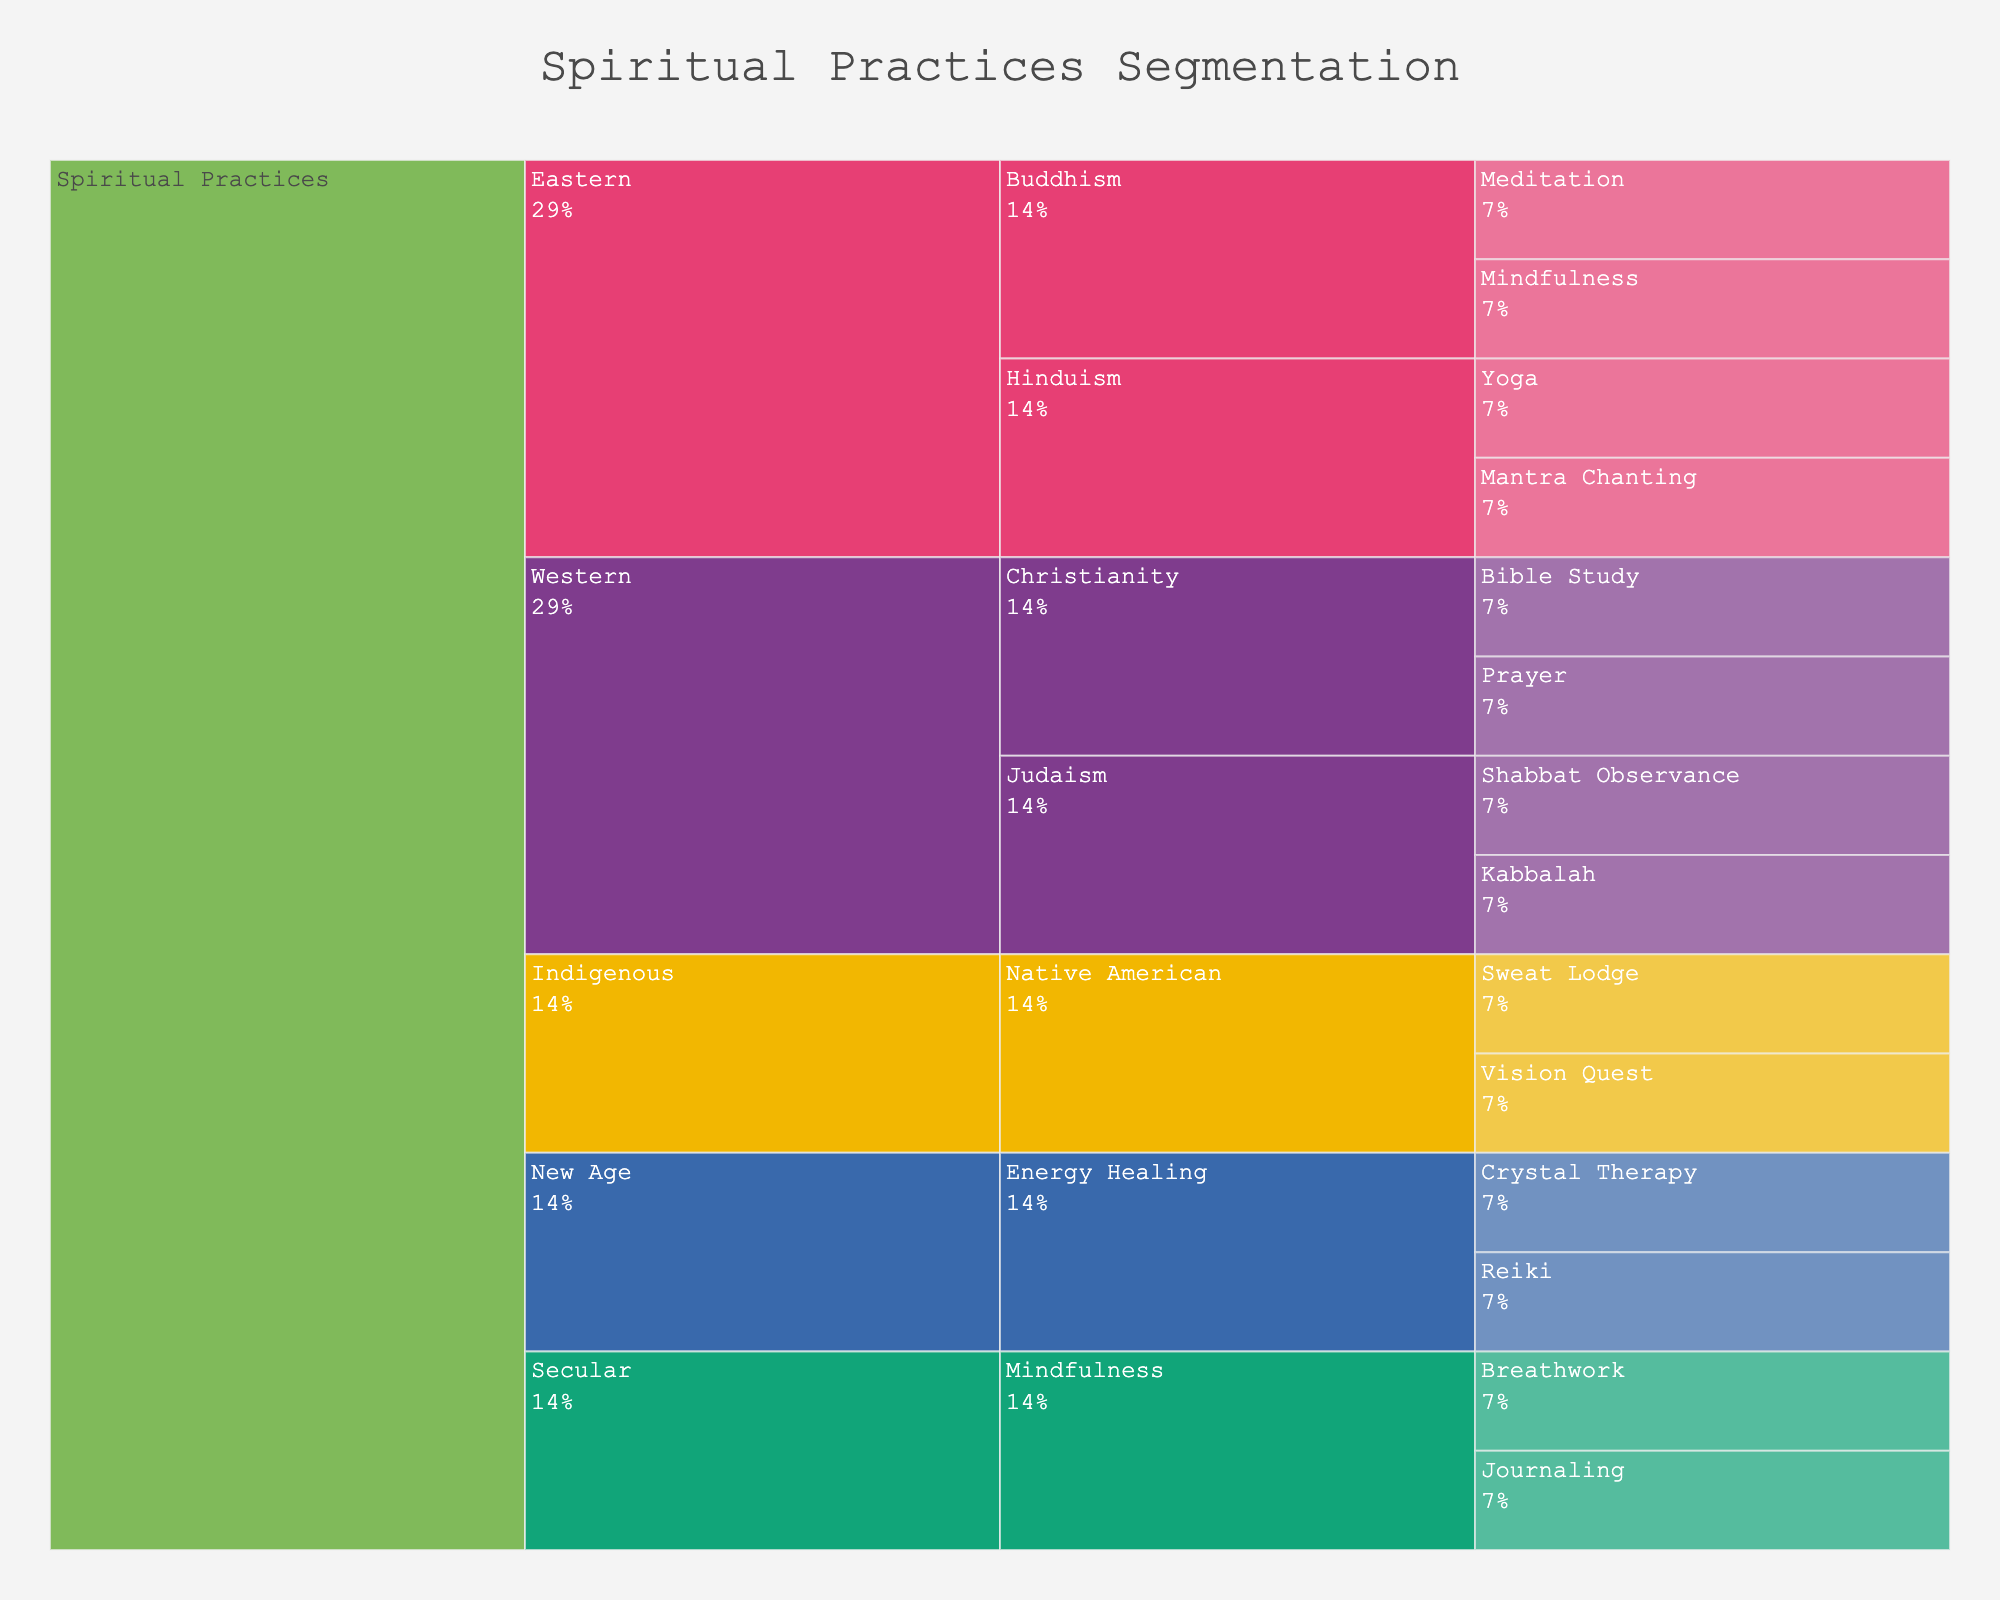What is the title of the figure? The title is usually located at the top center of the chart.
Answer: Spiritual Practices Segmentation Which belief system under "Western" has the most practices listed? Look at the branches stemming from "Western" and compare the number of practices under each belief system.
Answer: Christianity How many practices are listed under "Eastern"? Count all the practices that fall under the "Eastern" category.
Answer: 4 How does the number of practices in "New Age" compare to "Secular"? Count the practices under each category and compare the totals.
Answer: New Age has 2, Secular has 2 What percentage of the total practices does "Yoga" represent? Find the total number of practices and then calculate the percentage that "Yoga" represents. There are 14 practices in total, so the calculation is 1/14.
Answer: 7.1% What unique cultural origins are represented in the chart? Identify all the distinct cultural origins listed in the "category" section of the icicle chart.
Answer: Eastern, Western, Indigenous, New Age, Secular Which practice is shared between "Eastern" and "Secular"? Look at the practices listed under "Eastern" and "Secular" to find any that are the same.
Answer: Mindfulness What is the most common type of practice listed in the chart? Identify the practice type that appears most frequently across all categories.
Answer: Mindfulness What two practices fall under "Energy Healing"? Check the branches under "New Age" and identify the practices listed.
Answer: Reiki, Crystal Therapy Between "Prayer" and "Meditation," which practice falls under more than one category? Compare the categories and subcategories for "Prayer" and "Meditation" to see if either falls under multiple categories.
Answer: Meditation 